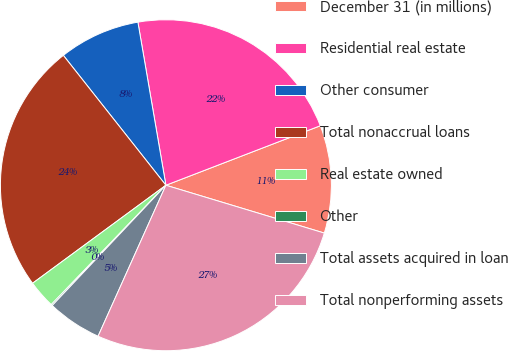Convert chart to OTSL. <chart><loc_0><loc_0><loc_500><loc_500><pie_chart><fcel>December 31 (in millions)<fcel>Residential real estate<fcel>Other consumer<fcel>Total nonaccrual loans<fcel>Real estate owned<fcel>Other<fcel>Total assets acquired in loan<fcel>Total nonperforming assets<nl><fcel>10.52%<fcel>21.85%<fcel>7.93%<fcel>24.45%<fcel>2.73%<fcel>0.13%<fcel>5.33%<fcel>27.05%<nl></chart> 